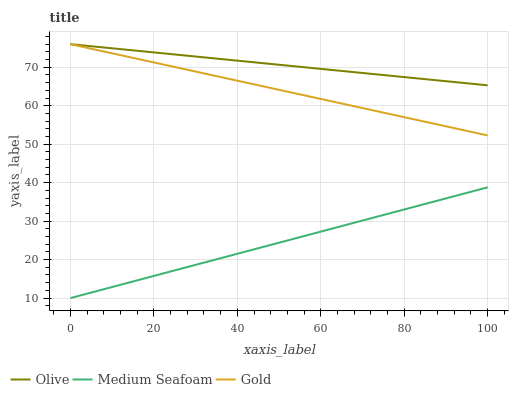Does Medium Seafoam have the minimum area under the curve?
Answer yes or no. Yes. Does Olive have the maximum area under the curve?
Answer yes or no. Yes. Does Gold have the minimum area under the curve?
Answer yes or no. No. Does Gold have the maximum area under the curve?
Answer yes or no. No. Is Medium Seafoam the smoothest?
Answer yes or no. Yes. Is Gold the roughest?
Answer yes or no. Yes. Is Gold the smoothest?
Answer yes or no. No. Is Medium Seafoam the roughest?
Answer yes or no. No. Does Gold have the lowest value?
Answer yes or no. No. Does Gold have the highest value?
Answer yes or no. Yes. Does Medium Seafoam have the highest value?
Answer yes or no. No. Is Medium Seafoam less than Olive?
Answer yes or no. Yes. Is Olive greater than Medium Seafoam?
Answer yes or no. Yes. Does Medium Seafoam intersect Olive?
Answer yes or no. No. 